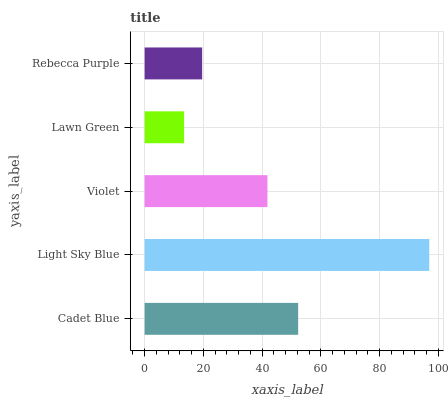Is Lawn Green the minimum?
Answer yes or no. Yes. Is Light Sky Blue the maximum?
Answer yes or no. Yes. Is Violet the minimum?
Answer yes or no. No. Is Violet the maximum?
Answer yes or no. No. Is Light Sky Blue greater than Violet?
Answer yes or no. Yes. Is Violet less than Light Sky Blue?
Answer yes or no. Yes. Is Violet greater than Light Sky Blue?
Answer yes or no. No. Is Light Sky Blue less than Violet?
Answer yes or no. No. Is Violet the high median?
Answer yes or no. Yes. Is Violet the low median?
Answer yes or no. Yes. Is Lawn Green the high median?
Answer yes or no. No. Is Cadet Blue the low median?
Answer yes or no. No. 